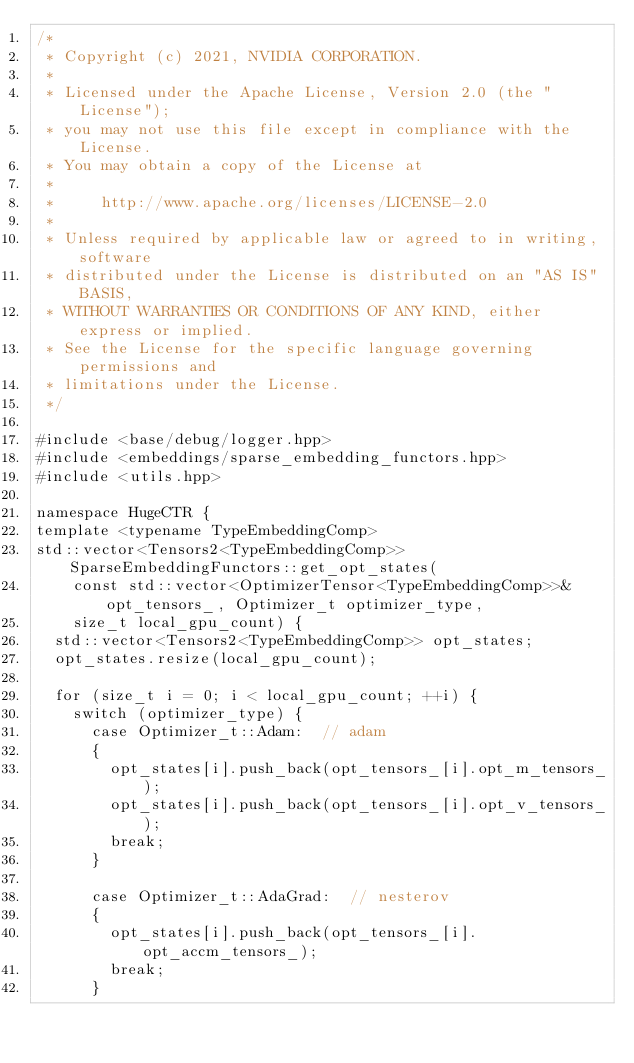<code> <loc_0><loc_0><loc_500><loc_500><_Cuda_>/*
 * Copyright (c) 2021, NVIDIA CORPORATION.
 *
 * Licensed under the Apache License, Version 2.0 (the "License");
 * you may not use this file except in compliance with the License.
 * You may obtain a copy of the License at
 *
 *     http://www.apache.org/licenses/LICENSE-2.0
 *
 * Unless required by applicable law or agreed to in writing, software
 * distributed under the License is distributed on an "AS IS" BASIS,
 * WITHOUT WARRANTIES OR CONDITIONS OF ANY KIND, either express or implied.
 * See the License for the specific language governing permissions and
 * limitations under the License.
 */

#include <base/debug/logger.hpp>
#include <embeddings/sparse_embedding_functors.hpp>
#include <utils.hpp>

namespace HugeCTR {
template <typename TypeEmbeddingComp>
std::vector<Tensors2<TypeEmbeddingComp>> SparseEmbeddingFunctors::get_opt_states(
    const std::vector<OptimizerTensor<TypeEmbeddingComp>>& opt_tensors_, Optimizer_t optimizer_type,
    size_t local_gpu_count) {
  std::vector<Tensors2<TypeEmbeddingComp>> opt_states;
  opt_states.resize(local_gpu_count);

  for (size_t i = 0; i < local_gpu_count; ++i) {
    switch (optimizer_type) {
      case Optimizer_t::Adam:  // adam
      {
        opt_states[i].push_back(opt_tensors_[i].opt_m_tensors_);
        opt_states[i].push_back(opt_tensors_[i].opt_v_tensors_);
        break;
      }

      case Optimizer_t::AdaGrad:  // nesterov
      {
        opt_states[i].push_back(opt_tensors_[i].opt_accm_tensors_);
        break;
      }</code> 